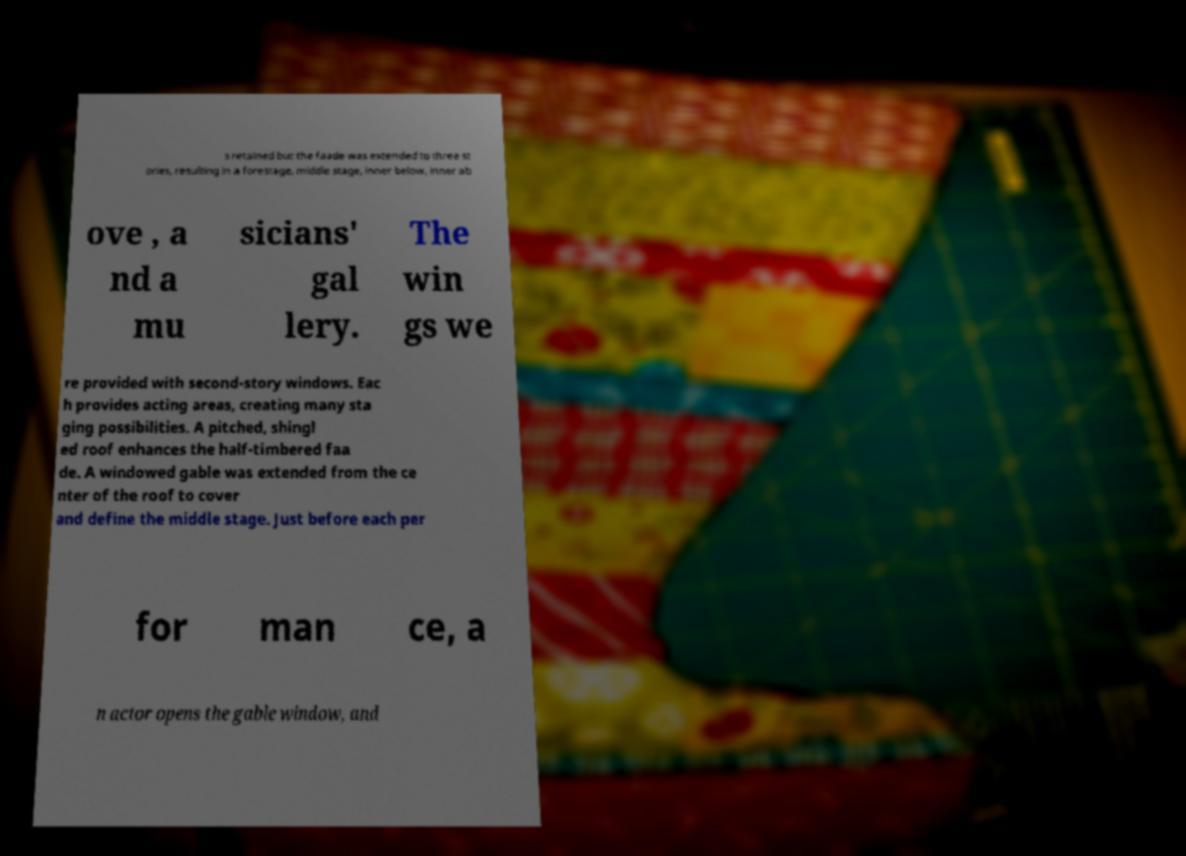Please read and relay the text visible in this image. What does it say? s retained but the faade was extended to three st ories, resulting in a forestage, middle stage, inner below, inner ab ove , a nd a mu sicians' gal lery. The win gs we re provided with second-story windows. Eac h provides acting areas, creating many sta ging possibilities. A pitched, shingl ed roof enhances the half-timbered faa de. A windowed gable was extended from the ce nter of the roof to cover and define the middle stage. Just before each per for man ce, a n actor opens the gable window, and 